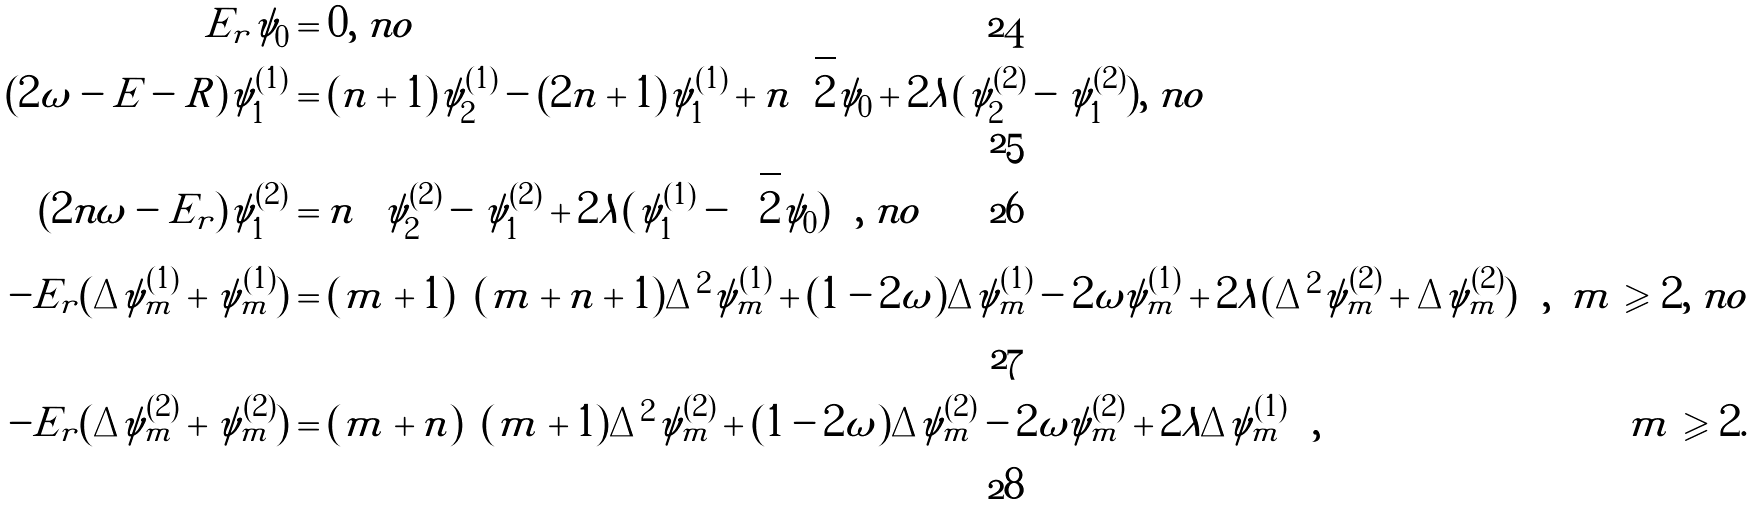<formula> <loc_0><loc_0><loc_500><loc_500>E _ { r } \psi _ { 0 } & = 0 , \ n o \\ ( 2 \omega - E - R ) \psi ^ { ( 1 ) } _ { 1 } & = ( n + 1 ) \psi ^ { ( 1 ) } _ { 2 } - ( 2 n + 1 ) \psi ^ { ( 1 ) } _ { 1 } + n \sqrt { 2 } \psi _ { 0 } + 2 \lambda ( \psi ^ { ( 2 ) } _ { 2 } - \psi ^ { ( 2 ) } _ { 1 } ) , \ n o \\ ( 2 n \omega - E _ { r } ) \psi ^ { ( 2 ) } _ { 1 } & = n \left ( \psi ^ { ( 2 ) } _ { 2 } - \psi ^ { ( 2 ) } _ { 1 } + 2 \lambda ( \psi ^ { ( 1 ) } _ { 1 } - \sqrt { 2 } \psi _ { 0 } ) \right ) , \ n o \\ - E _ { r } ( \Delta \psi ^ { ( 1 ) } _ { m } + \psi ^ { ( 1 ) } _ { m } ) & = ( m + 1 ) \left ( ( m + n + 1 ) \Delta ^ { 2 } \psi ^ { ( 1 ) } _ { m } + ( 1 - 2 \omega ) \Delta \psi ^ { ( 1 ) } _ { m } - 2 \omega \psi ^ { ( 1 ) } _ { m } + 2 \lambda ( \Delta ^ { 2 } \psi ^ { ( 2 ) } _ { m } + \Delta \psi ^ { ( 2 ) } _ { m } ) \right ) , & m \geqslant 2 , \ n o \\ - E _ { r } ( \Delta \psi ^ { ( 2 ) } _ { m } + \psi ^ { ( 2 ) } _ { m } ) & = ( m + n ) \left ( ( m + 1 ) \Delta ^ { 2 } \psi ^ { ( 2 ) } _ { m } + ( 1 - 2 \omega ) \Delta \psi ^ { ( 2 ) } _ { m } - 2 \omega \psi ^ { ( 2 ) } _ { m } + 2 \lambda \Delta \psi ^ { ( 1 ) } _ { m } \right ) , & m \geqslant 2 .</formula> 